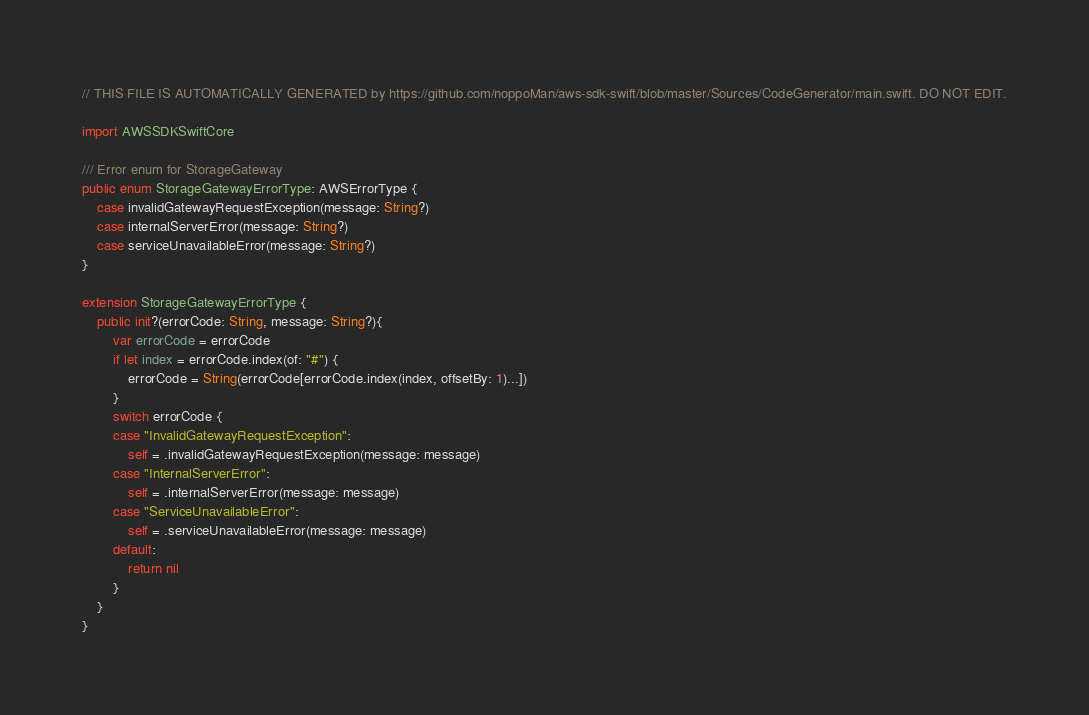<code> <loc_0><loc_0><loc_500><loc_500><_Swift_>// THIS FILE IS AUTOMATICALLY GENERATED by https://github.com/noppoMan/aws-sdk-swift/blob/master/Sources/CodeGenerator/main.swift. DO NOT EDIT.

import AWSSDKSwiftCore

/// Error enum for StorageGateway
public enum StorageGatewayErrorType: AWSErrorType {
    case invalidGatewayRequestException(message: String?)
    case internalServerError(message: String?)
    case serviceUnavailableError(message: String?)
}

extension StorageGatewayErrorType {
    public init?(errorCode: String, message: String?){
        var errorCode = errorCode
        if let index = errorCode.index(of: "#") {
            errorCode = String(errorCode[errorCode.index(index, offsetBy: 1)...])
        }
        switch errorCode {
        case "InvalidGatewayRequestException":
            self = .invalidGatewayRequestException(message: message)
        case "InternalServerError":
            self = .internalServerError(message: message)
        case "ServiceUnavailableError":
            self = .serviceUnavailableError(message: message)
        default:
            return nil
        }
    }
}</code> 